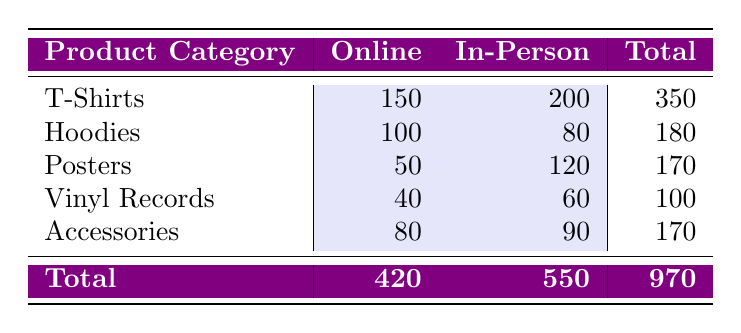What are the total sales for T-Shirts? The total sales for T-Shirts can be found by adding the sales from both online and in-person channels. Online sales for T-Shirts are 150 and in-person sales are 200. So, the total is 150 + 200 = 350.
Answer: 350 How many more sales were made through the in-person channel compared to the online channel? To find how many more sales were made in-person than online, we add the total sales for both channels. The total sales for in-person is 550 and for online is 420. Now, we subtract the online total from the in-person total: 550 - 420 = 130.
Answer: 130 Is the sales total for Vinyl Records greater than for Hoodies? The total sales for Vinyl Records is 100, while for Hoodies it is 180. Since 100 is less than 180, the statement is false.
Answer: No What is the average sales for all product categories in the online channel? To calculate the average sales for the online channel, we first sum the online sales: 150 + 100 + 50 + 40 + 80 = 420. Then, we divide this total by the number of product categories, which is 5. Therefore, the average is 420 / 5 = 84.
Answer: 84 Which product category has the highest total sales and what is the value? To determine which product category has the highest total sales, we must first calculate the totals for each category: T-Shirts (350), Hoodies (180), Posters (170), Vinyl Records (100), and Accessories (170). T-Shirts has the highest total sales at 350.
Answer: T-Shirts, 350 What is the ratio of online sales to in-person sales across all product categories? To find the ratio of online to in-person sales, we first calculate the totals for each channel: online total is 420 and in-person total is 550. The ratio is then calculated as 420:550. Simplifying this gives us 42:55.
Answer: 42:55 Does the sales for Accessories in person exceed those of Posters in person? The sales for Accessories in person are 90, while the sales for Posters in person are 120. Since 90 is less than 120, the statement is false.
Answer: No How much is the total profit obtained through online sales? The total profit from online sales can be determined by adding all online sales figures: 150 (T-Shirts) + 100 (Hoodies) + 50 (Posters) + 40 (Vinyl Records) + 80 (Accessories) = 420.
Answer: 420 How many categories have higher total sales in person compared to online? The total sales for each category are: T-Shirts (350 in-person, 150 online), Hoodies (80 in-person, 100 online), Posters (120 in-person, 50 online), Vinyl Records (60 in-person, 40 online), Accessories (90 in-person, 80 online). Categories with higher in-person sales are T-Shirts, Posters, and Accessories. Thus, there are 3 categories with higher in-person sales.
Answer: 3 